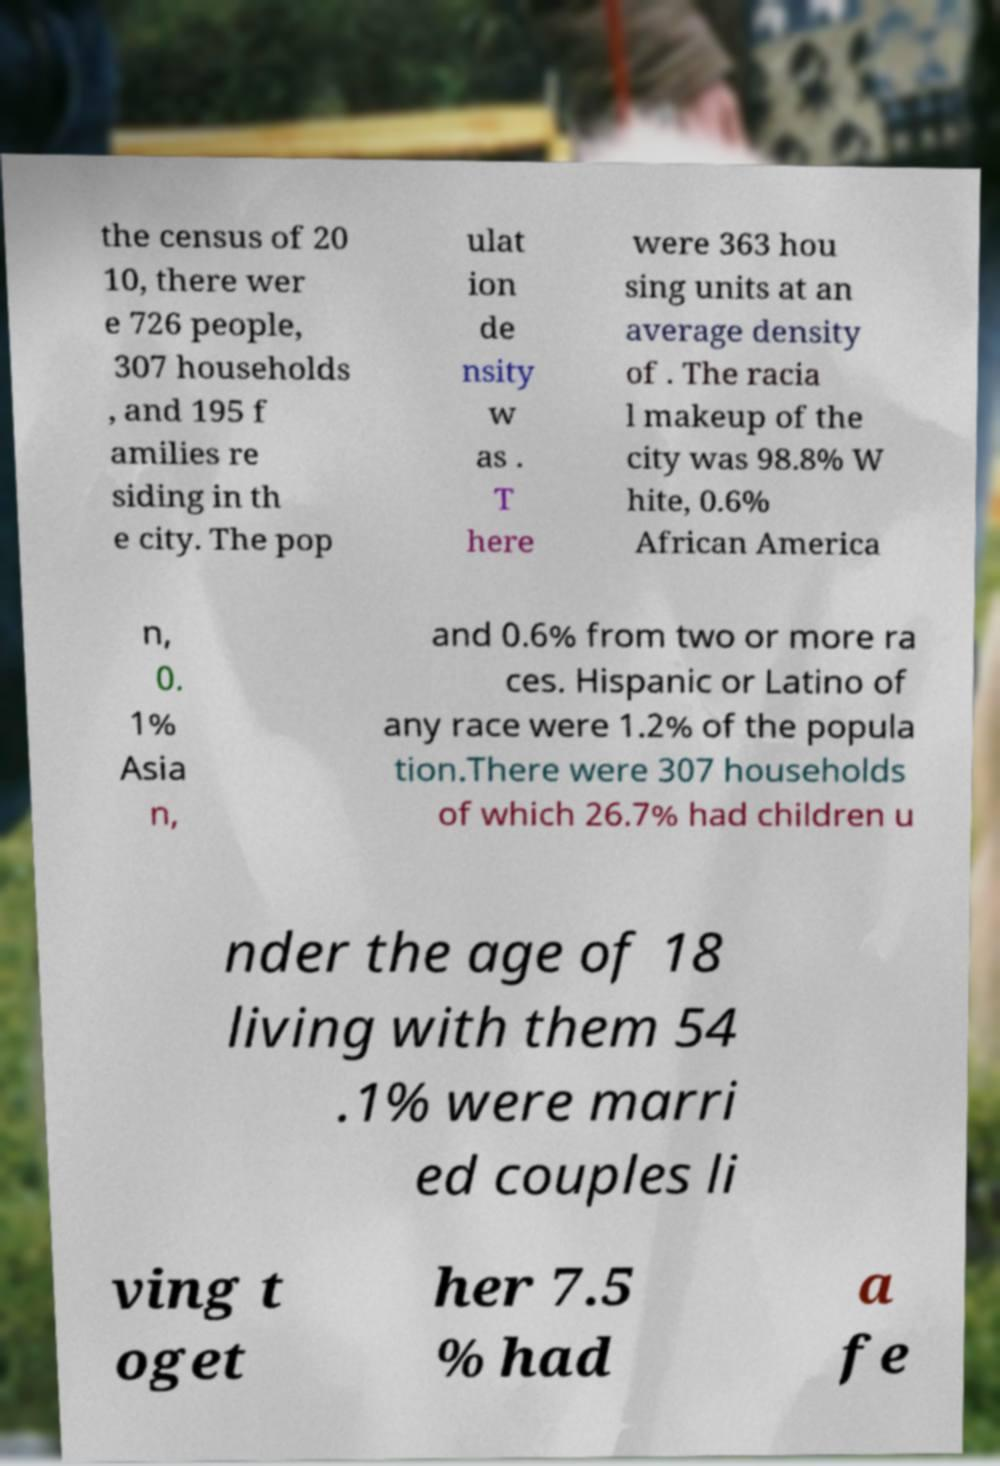Please identify and transcribe the text found in this image. the census of 20 10, there wer e 726 people, 307 households , and 195 f amilies re siding in th e city. The pop ulat ion de nsity w as . T here were 363 hou sing units at an average density of . The racia l makeup of the city was 98.8% W hite, 0.6% African America n, 0. 1% Asia n, and 0.6% from two or more ra ces. Hispanic or Latino of any race were 1.2% of the popula tion.There were 307 households of which 26.7% had children u nder the age of 18 living with them 54 .1% were marri ed couples li ving t oget her 7.5 % had a fe 